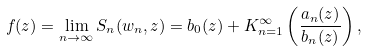<formula> <loc_0><loc_0><loc_500><loc_500>f ( z ) = \lim _ { n \rightarrow \infty } S _ { n } ( w _ { n } , z ) = b _ { 0 } ( z ) + K _ { n = 1 } ^ { \infty } \left ( \frac { a _ { n } ( z ) } { b _ { n } ( z ) } \right ) ,</formula> 